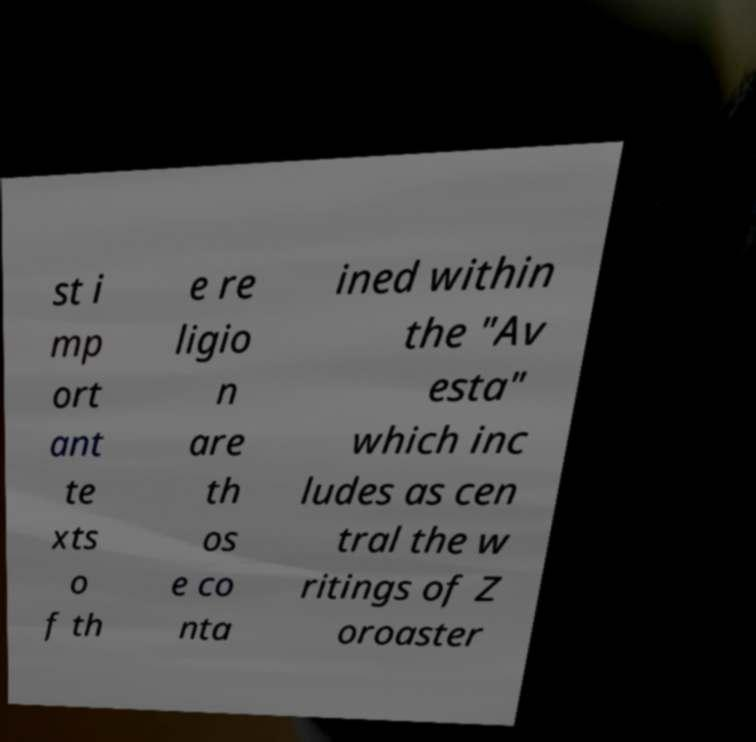Can you read and provide the text displayed in the image?This photo seems to have some interesting text. Can you extract and type it out for me? st i mp ort ant te xts o f th e re ligio n are th os e co nta ined within the "Av esta" which inc ludes as cen tral the w ritings of Z oroaster 